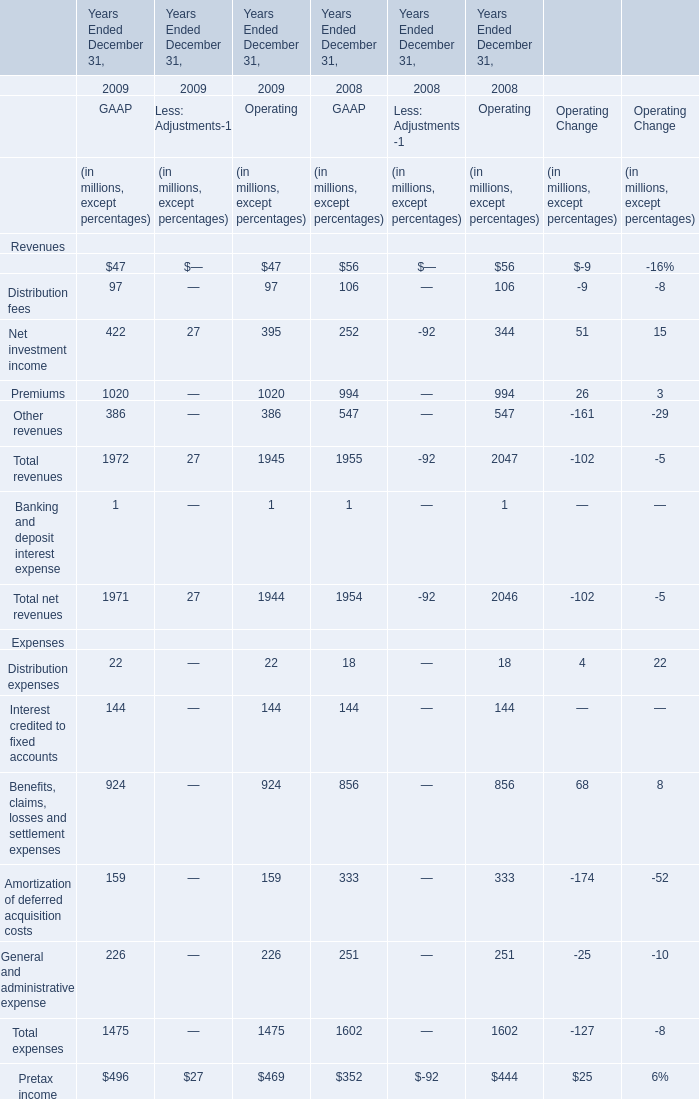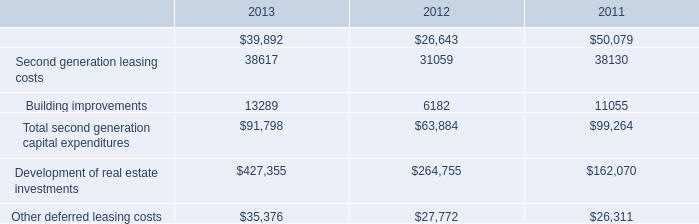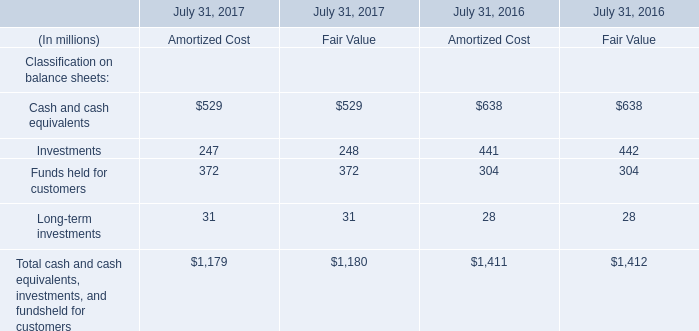What is the sum of Total expenses of GAAP in 2009 and Funds held for customers of Fair Value in 2017? (in million) 
Computations: (1475 + 372)
Answer: 1847.0. 